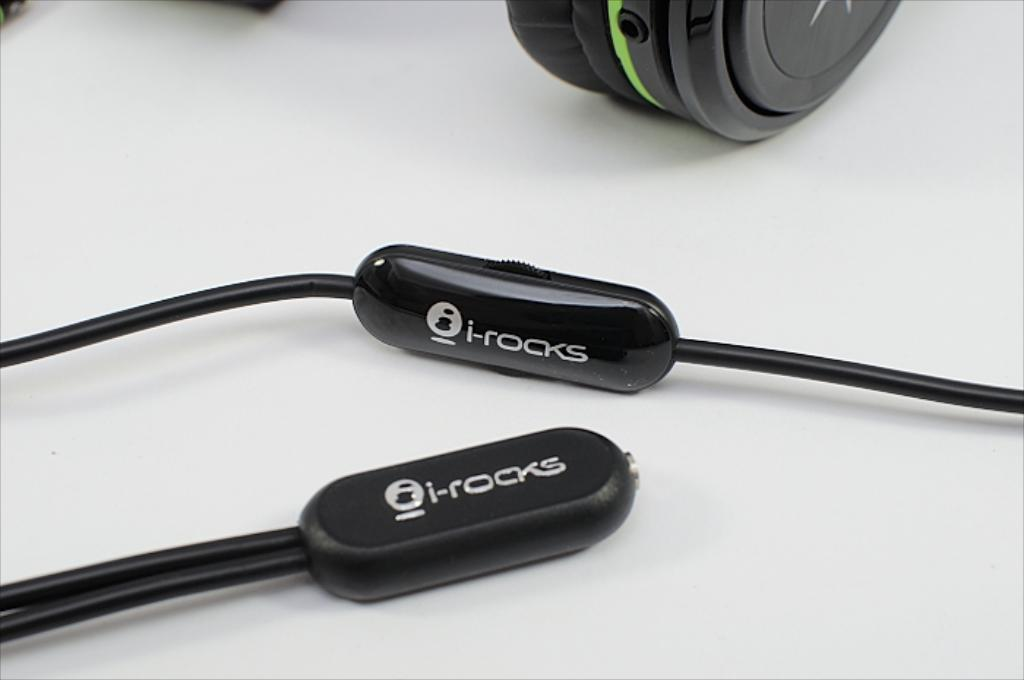<image>
Offer a succinct explanation of the picture presented. A headphone cable with the logo for the brand "i-rocks" sits next to an earphone. 